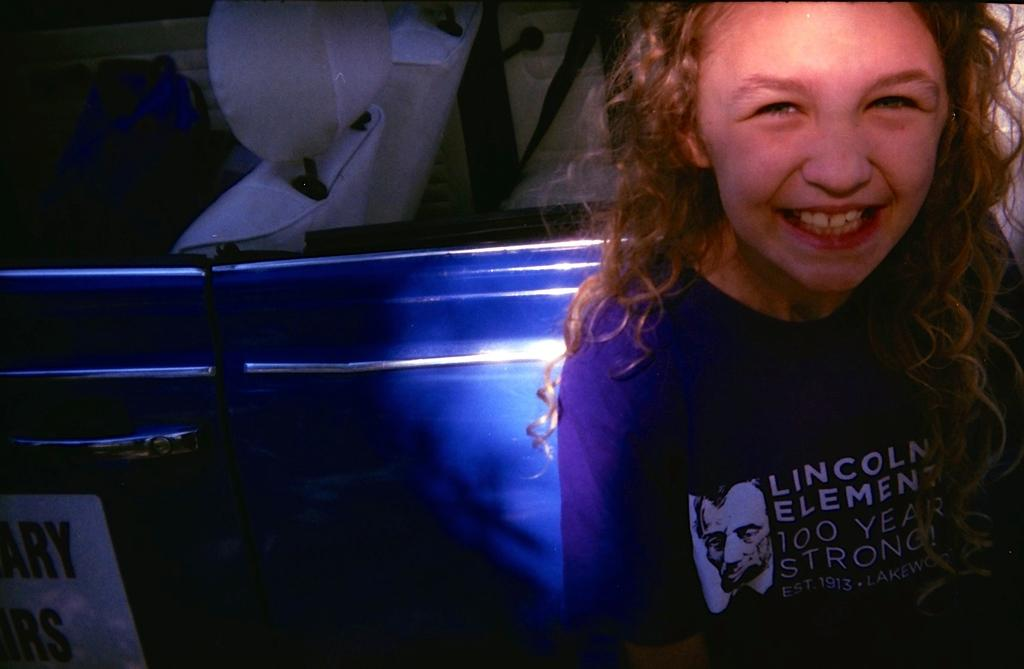Who is the main subject in the image? There is a girl in the image in the image. What is the girl wearing? The girl is wearing a blue top. What else can be seen in the image besides the girl? There is text written on a board attached to a vehicle in the image. How many dogs are sitting next to the girl in the image? There are no dogs present in the image. What type of stew is being served in the image? There is no stew present in the image. 